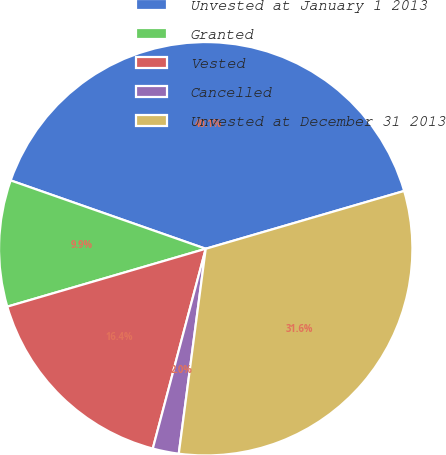Convert chart. <chart><loc_0><loc_0><loc_500><loc_500><pie_chart><fcel>Unvested at January 1 2013<fcel>Granted<fcel>Vested<fcel>Cancelled<fcel>Unvested at December 31 2013<nl><fcel>40.12%<fcel>9.88%<fcel>16.36%<fcel>2.04%<fcel>31.59%<nl></chart> 